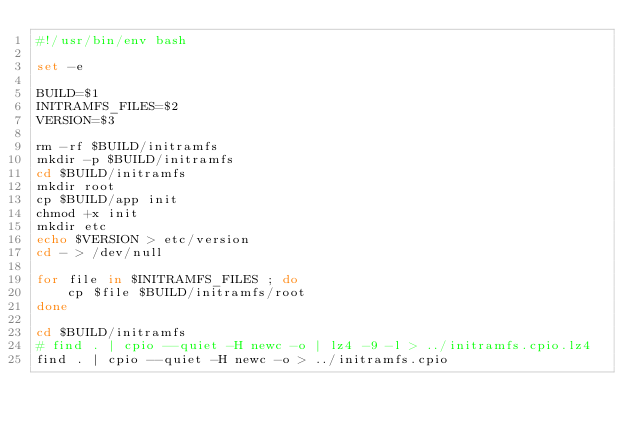<code> <loc_0><loc_0><loc_500><loc_500><_Bash_>#!/usr/bin/env bash

set -e

BUILD=$1
INITRAMFS_FILES=$2
VERSION=$3

rm -rf $BUILD/initramfs
mkdir -p $BUILD/initramfs
cd $BUILD/initramfs
mkdir root
cp $BUILD/app init
chmod +x init
mkdir etc
echo $VERSION > etc/version
cd - > /dev/null

for file in $INITRAMFS_FILES ; do
    cp $file $BUILD/initramfs/root
done

cd $BUILD/initramfs
# find . | cpio --quiet -H newc -o | lz4 -9 -l > ../initramfs.cpio.lz4
find . | cpio --quiet -H newc -o > ../initramfs.cpio
</code> 